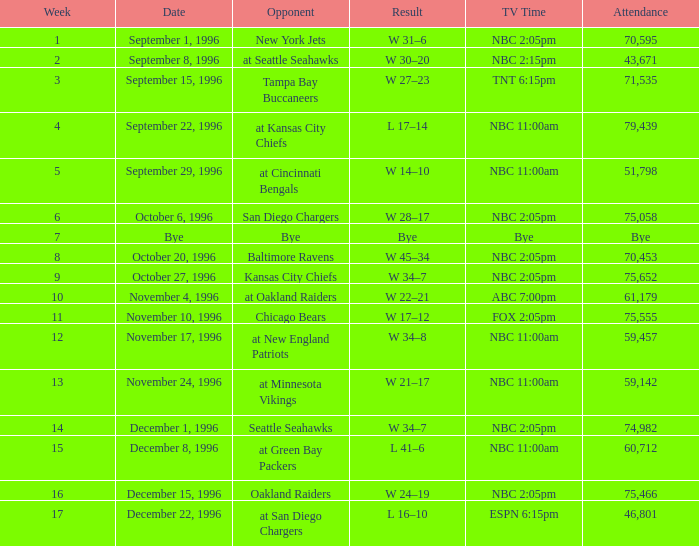Write the full table. {'header': ['Week', 'Date', 'Opponent', 'Result', 'TV Time', 'Attendance'], 'rows': [['1', 'September 1, 1996', 'New York Jets', 'W 31–6', 'NBC 2:05pm', '70,595'], ['2', 'September 8, 1996', 'at Seattle Seahawks', 'W 30–20', 'NBC 2:15pm', '43,671'], ['3', 'September 15, 1996', 'Tampa Bay Buccaneers', 'W 27–23', 'TNT 6:15pm', '71,535'], ['4', 'September 22, 1996', 'at Kansas City Chiefs', 'L 17–14', 'NBC 11:00am', '79,439'], ['5', 'September 29, 1996', 'at Cincinnati Bengals', 'W 14–10', 'NBC 11:00am', '51,798'], ['6', 'October 6, 1996', 'San Diego Chargers', 'W 28–17', 'NBC 2:05pm', '75,058'], ['7', 'Bye', 'Bye', 'Bye', 'Bye', 'Bye'], ['8', 'October 20, 1996', 'Baltimore Ravens', 'W 45–34', 'NBC 2:05pm', '70,453'], ['9', 'October 27, 1996', 'Kansas City Chiefs', 'W 34–7', 'NBC 2:05pm', '75,652'], ['10', 'November 4, 1996', 'at Oakland Raiders', 'W 22–21', 'ABC 7:00pm', '61,179'], ['11', 'November 10, 1996', 'Chicago Bears', 'W 17–12', 'FOX 2:05pm', '75,555'], ['12', 'November 17, 1996', 'at New England Patriots', 'W 34–8', 'NBC 11:00am', '59,457'], ['13', 'November 24, 1996', 'at Minnesota Vikings', 'W 21–17', 'NBC 11:00am', '59,142'], ['14', 'December 1, 1996', 'Seattle Seahawks', 'W 34–7', 'NBC 2:05pm', '74,982'], ['15', 'December 8, 1996', 'at Green Bay Packers', 'L 41–6', 'NBC 11:00am', '60,712'], ['16', 'December 15, 1996', 'Oakland Raiders', 'W 24–19', 'NBC 2:05pm', '75,466'], ['17', 'December 22, 1996', 'at San Diego Chargers', 'L 16–10', 'ESPN 6:15pm', '46,801']]} WHAT IS THE TV TIME FOR NOVEMBER 10, 1996? FOX 2:05pm. 